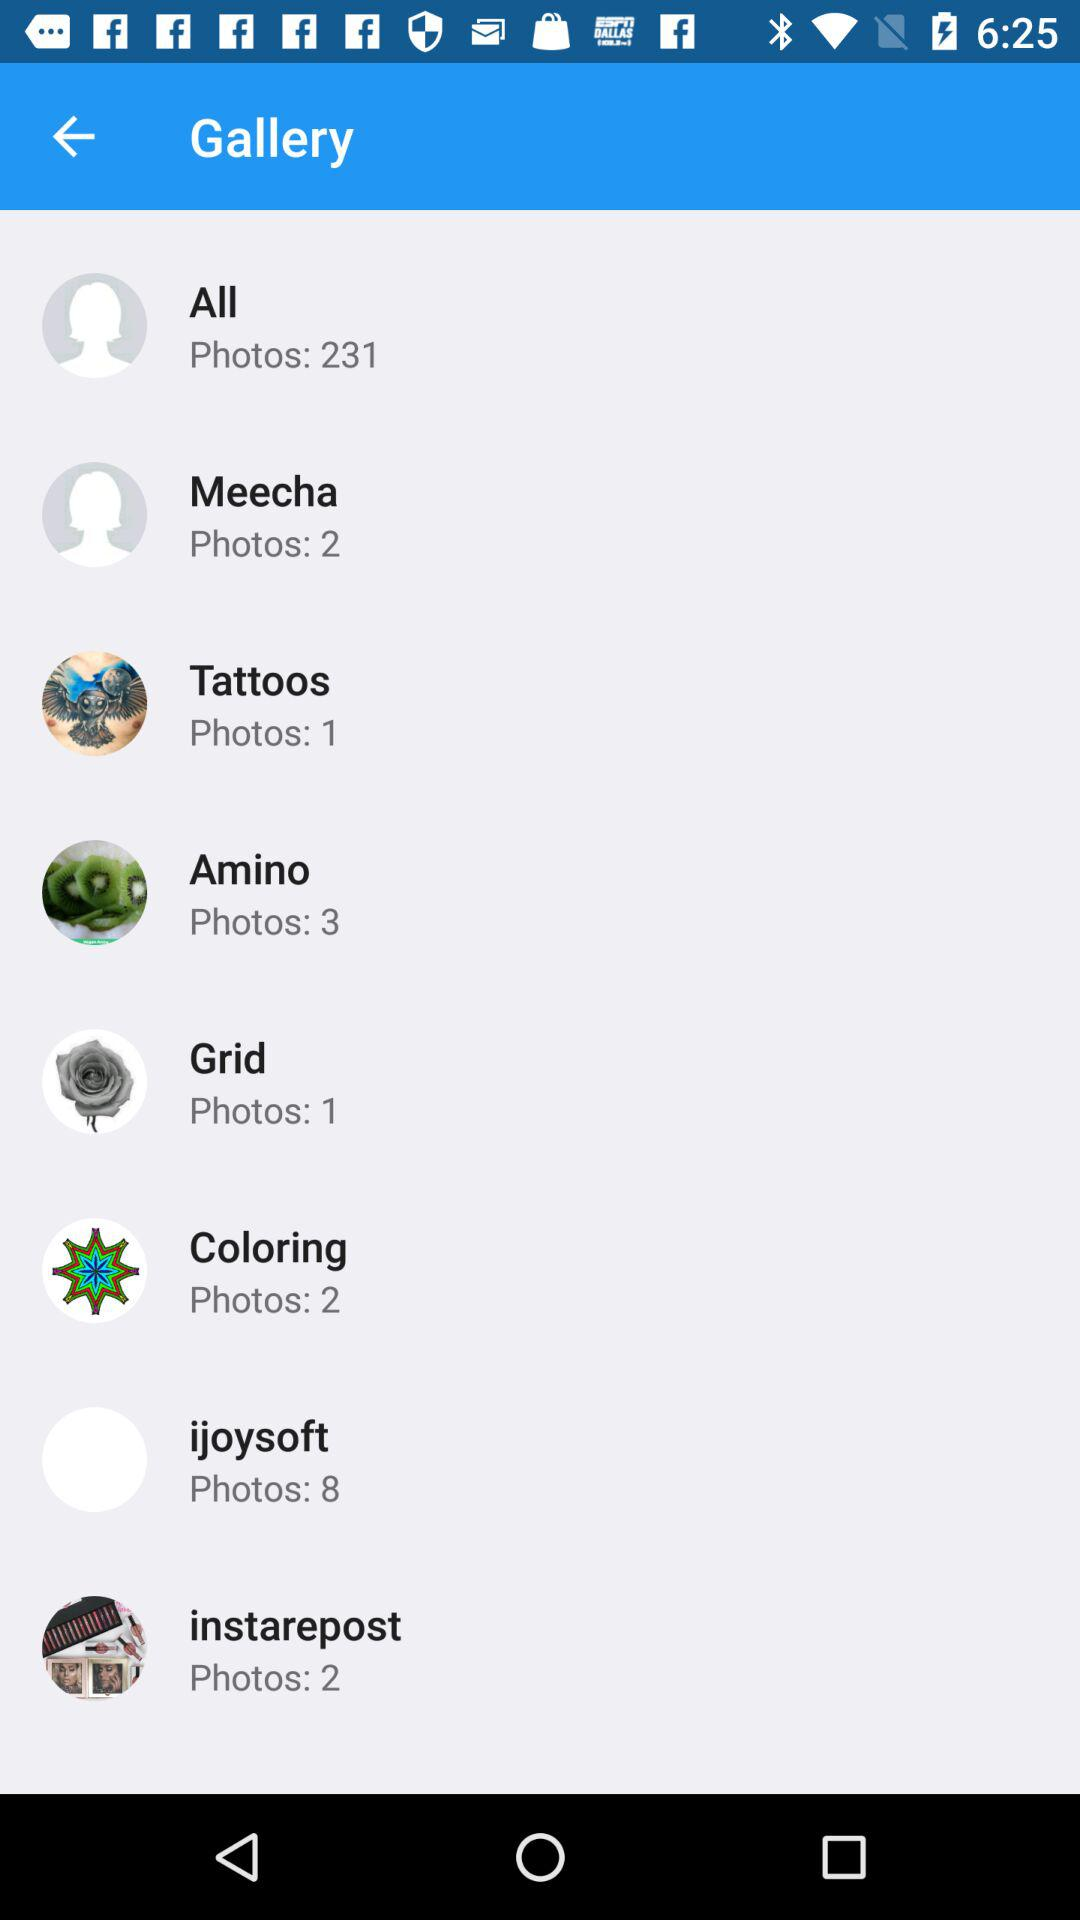When was the most recent photo posted in "All"?
When the provided information is insufficient, respond with <no answer>. <no answer> 